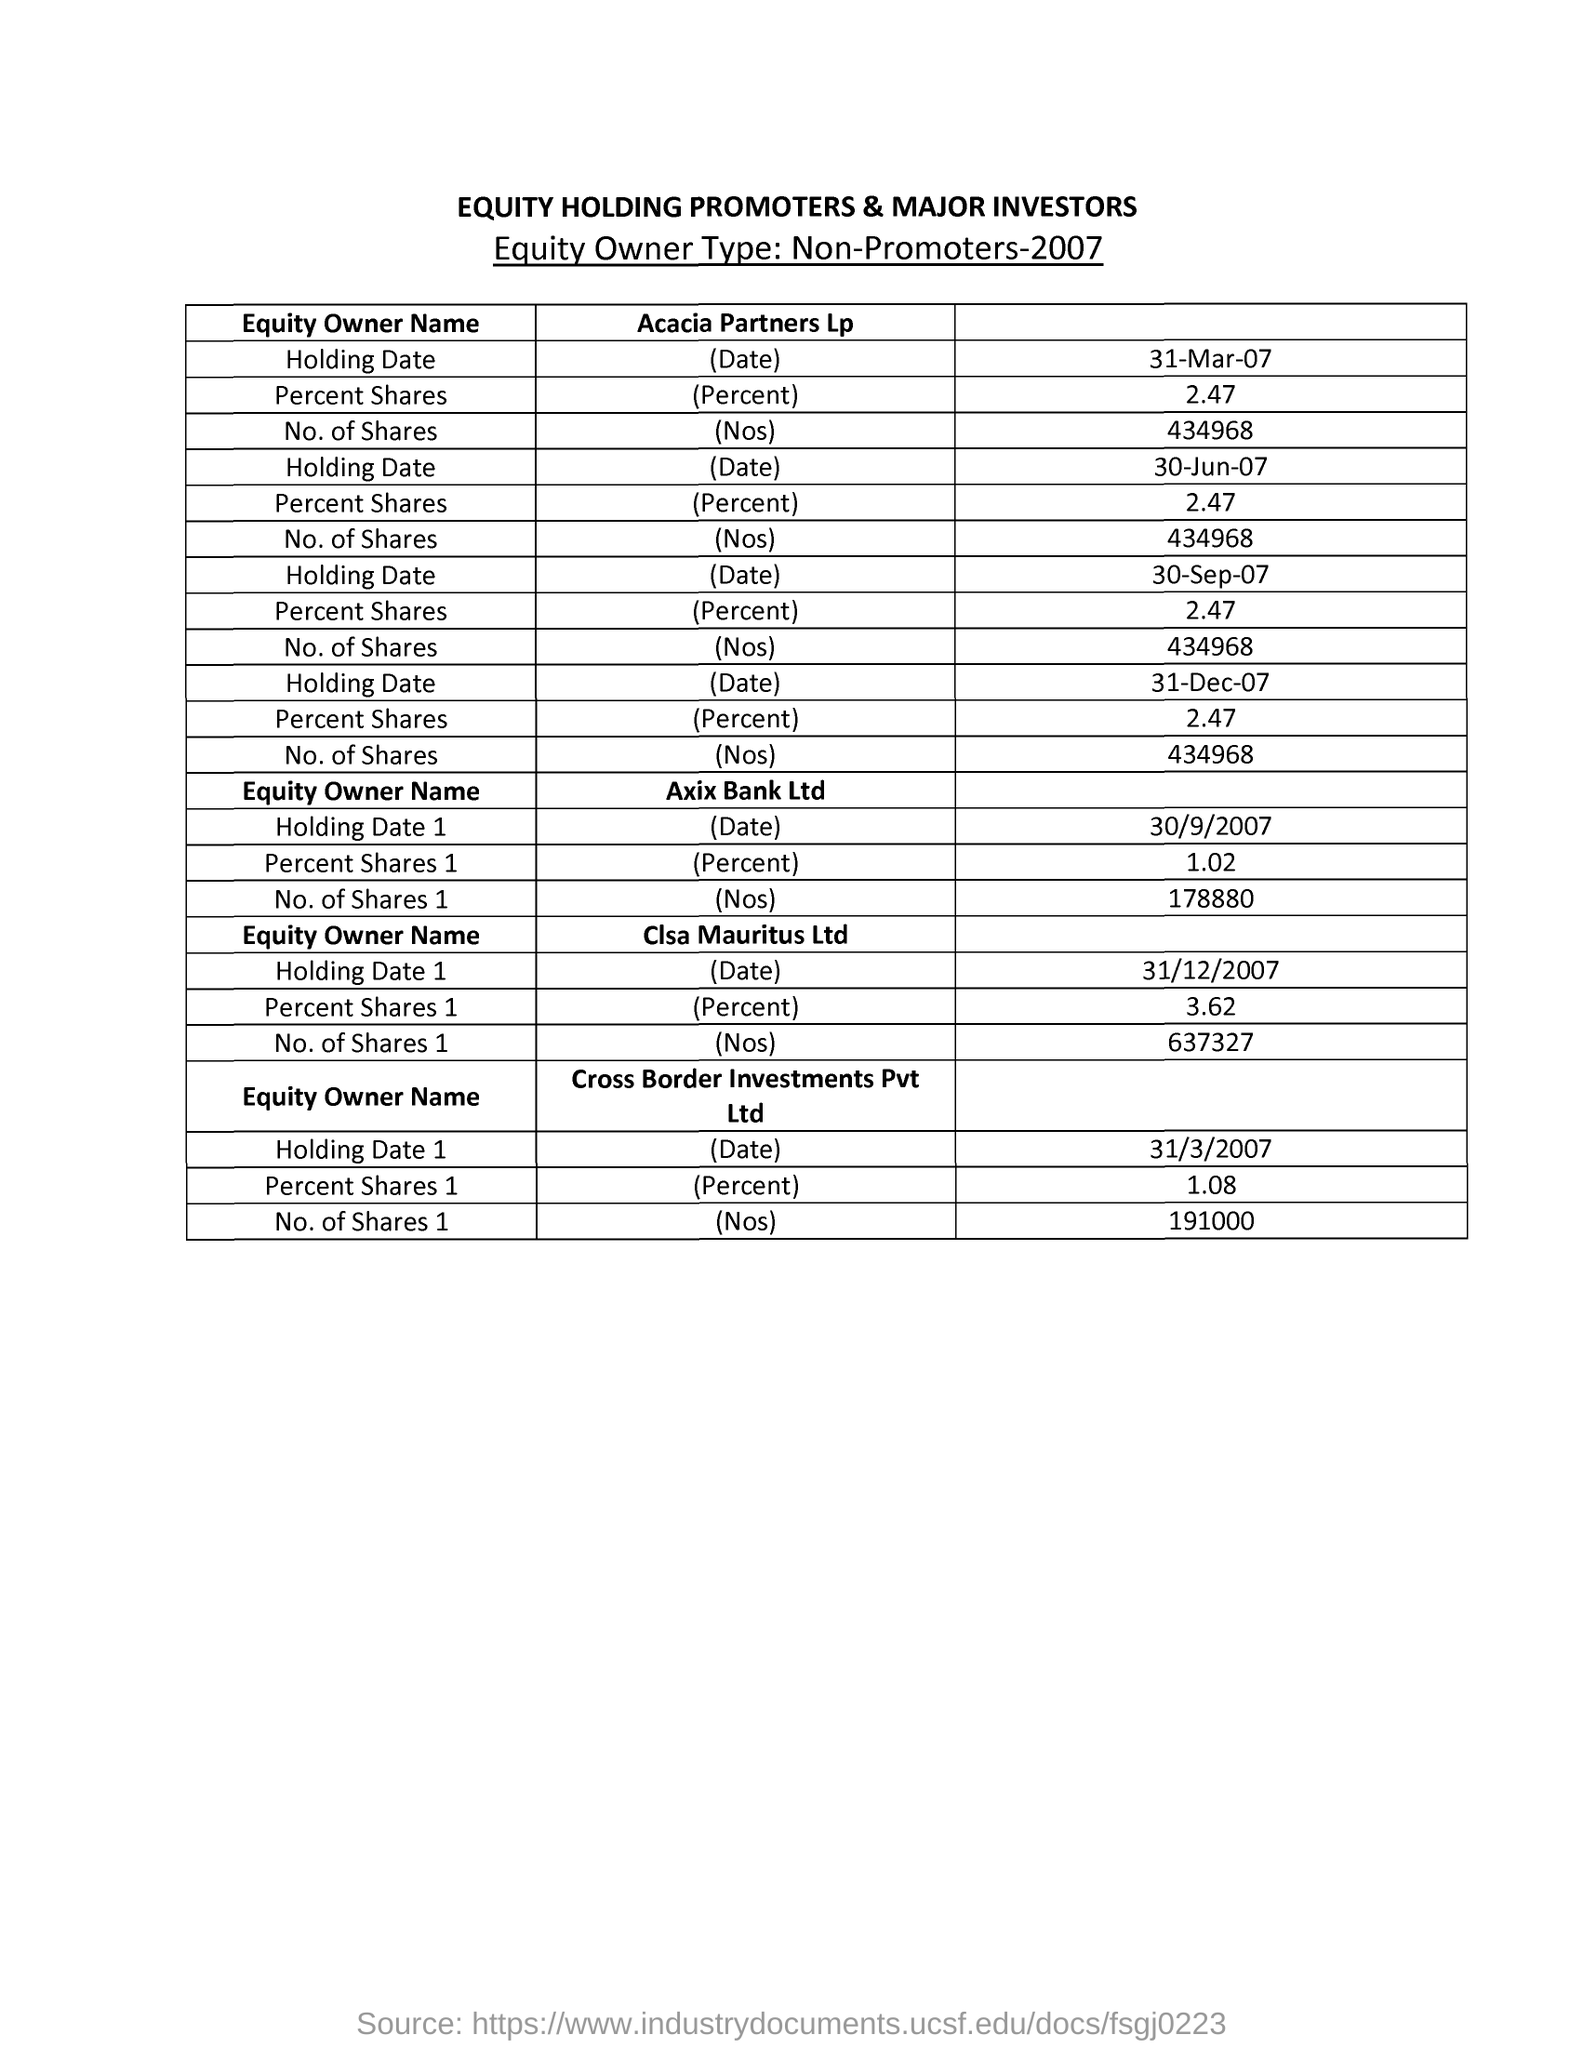What is the title of the document?
Your answer should be very brief. EQUITY HOLDING PROMOTERS & MAJOR INVESTORS. How much is the Percent Shares of 'Acacia Partners Lp' in date '31-Mar-07'?
Ensure brevity in your answer.  2.47. How many 'No. of Shares' is for 'Acacia Partners Lp' for the 'Holding Date' '30-Jun-07' ?
Offer a very short reply. 434968. What is the next 'Holding Date' after '30-Sep-07' of 'Acacia Partners Lp'?
Give a very brief answer. 31-Dec-07. What is the second Equity Owner Name?
Ensure brevity in your answer.  Axix Bank Ltd. What is the Holding Date of 'Axix Bank Ltd'?
Your answer should be very brief. 30/9/2007. How many 'No. of Shares' is for 'Axix Bank Ltd'?
Provide a succinct answer. 178880. Which 'Equity Owner' has a Percent Share of '1.08' for the date 31/3/2007 ?
Provide a succinct answer. Cross Border Investments Pvt Ltd. Which 'Equity Owner' has No. of Shares equal to '637327' in date 31/12/2007?
Provide a succinct answer. Clsa Mauritus Ltd. 